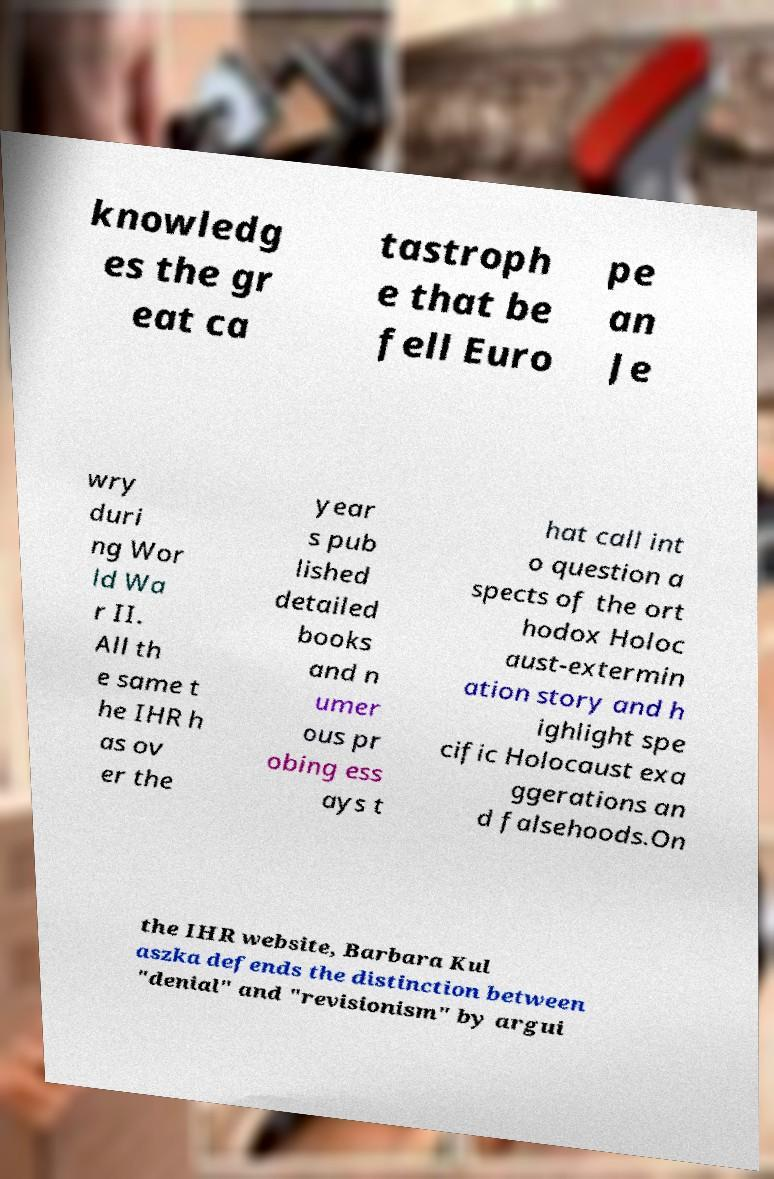Could you extract and type out the text from this image? knowledg es the gr eat ca tastroph e that be fell Euro pe an Je wry duri ng Wor ld Wa r II. All th e same t he IHR h as ov er the year s pub lished detailed books and n umer ous pr obing ess ays t hat call int o question a spects of the ort hodox Holoc aust-extermin ation story and h ighlight spe cific Holocaust exa ggerations an d falsehoods.On the IHR website, Barbara Kul aszka defends the distinction between "denial" and "revisionism" by argui 